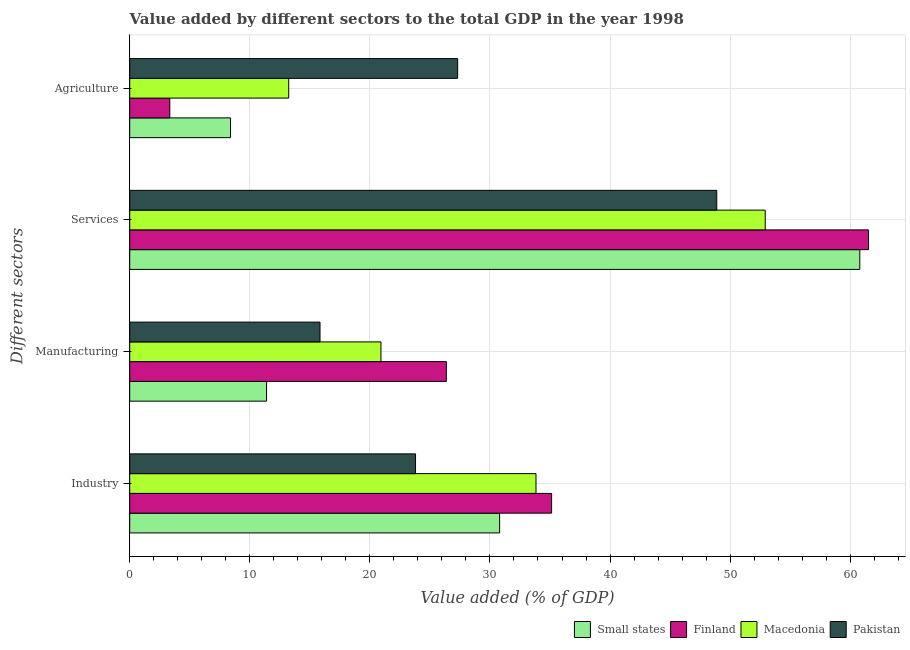How many different coloured bars are there?
Provide a short and direct response. 4. How many groups of bars are there?
Offer a very short reply. 4. How many bars are there on the 3rd tick from the bottom?
Your answer should be compact. 4. What is the label of the 4th group of bars from the top?
Provide a short and direct response. Industry. What is the value added by manufacturing sector in Pakistan?
Provide a succinct answer. 15.85. Across all countries, what is the maximum value added by agricultural sector?
Provide a succinct answer. 27.31. Across all countries, what is the minimum value added by services sector?
Offer a very short reply. 48.89. In which country was the value added by services sector minimum?
Provide a succinct answer. Pakistan. What is the total value added by agricultural sector in the graph?
Provide a succinct answer. 52.28. What is the difference between the value added by industrial sector in Finland and that in Pakistan?
Provide a succinct answer. 11.33. What is the difference between the value added by services sector in Small states and the value added by manufacturing sector in Macedonia?
Provide a succinct answer. 39.88. What is the average value added by industrial sector per country?
Make the answer very short. 30.89. What is the difference between the value added by manufacturing sector and value added by agricultural sector in Pakistan?
Provide a short and direct response. -11.46. What is the ratio of the value added by services sector in Macedonia to that in Finland?
Your answer should be compact. 0.86. Is the value added by services sector in Pakistan less than that in Macedonia?
Make the answer very short. Yes. Is the difference between the value added by industrial sector in Finland and Macedonia greater than the difference between the value added by manufacturing sector in Finland and Macedonia?
Provide a succinct answer. No. What is the difference between the highest and the second highest value added by agricultural sector?
Keep it short and to the point. 14.07. What is the difference between the highest and the lowest value added by industrial sector?
Keep it short and to the point. 11.33. In how many countries, is the value added by industrial sector greater than the average value added by industrial sector taken over all countries?
Provide a succinct answer. 2. What does the 1st bar from the top in Services represents?
Offer a very short reply. Pakistan. Is it the case that in every country, the sum of the value added by industrial sector and value added by manufacturing sector is greater than the value added by services sector?
Give a very brief answer. No. How many bars are there?
Your response must be concise. 16. Are all the bars in the graph horizontal?
Ensure brevity in your answer.  Yes. What is the difference between two consecutive major ticks on the X-axis?
Make the answer very short. 10. Are the values on the major ticks of X-axis written in scientific E-notation?
Ensure brevity in your answer.  No. Does the graph contain grids?
Your answer should be very brief. Yes. Where does the legend appear in the graph?
Provide a short and direct response. Bottom right. What is the title of the graph?
Your answer should be very brief. Value added by different sectors to the total GDP in the year 1998. What is the label or title of the X-axis?
Your answer should be very brief. Value added (% of GDP). What is the label or title of the Y-axis?
Provide a short and direct response. Different sectors. What is the Value added (% of GDP) in Small states in Industry?
Ensure brevity in your answer.  30.81. What is the Value added (% of GDP) of Finland in Industry?
Give a very brief answer. 35.13. What is the Value added (% of GDP) in Macedonia in Industry?
Your response must be concise. 33.83. What is the Value added (% of GDP) of Pakistan in Industry?
Provide a short and direct response. 23.8. What is the Value added (% of GDP) in Small states in Manufacturing?
Give a very brief answer. 11.4. What is the Value added (% of GDP) of Finland in Manufacturing?
Your response must be concise. 26.37. What is the Value added (% of GDP) in Macedonia in Manufacturing?
Offer a terse response. 20.92. What is the Value added (% of GDP) of Pakistan in Manufacturing?
Offer a terse response. 15.85. What is the Value added (% of GDP) of Small states in Services?
Keep it short and to the point. 60.8. What is the Value added (% of GDP) in Finland in Services?
Ensure brevity in your answer.  61.53. What is the Value added (% of GDP) in Macedonia in Services?
Offer a very short reply. 52.92. What is the Value added (% of GDP) in Pakistan in Services?
Keep it short and to the point. 48.89. What is the Value added (% of GDP) in Small states in Agriculture?
Make the answer very short. 8.39. What is the Value added (% of GDP) of Finland in Agriculture?
Keep it short and to the point. 3.34. What is the Value added (% of GDP) in Macedonia in Agriculture?
Offer a very short reply. 13.24. What is the Value added (% of GDP) in Pakistan in Agriculture?
Offer a terse response. 27.31. Across all Different sectors, what is the maximum Value added (% of GDP) in Small states?
Offer a terse response. 60.8. Across all Different sectors, what is the maximum Value added (% of GDP) in Finland?
Provide a short and direct response. 61.53. Across all Different sectors, what is the maximum Value added (% of GDP) of Macedonia?
Provide a succinct answer. 52.92. Across all Different sectors, what is the maximum Value added (% of GDP) of Pakistan?
Ensure brevity in your answer.  48.89. Across all Different sectors, what is the minimum Value added (% of GDP) in Small states?
Provide a succinct answer. 8.39. Across all Different sectors, what is the minimum Value added (% of GDP) in Finland?
Ensure brevity in your answer.  3.34. Across all Different sectors, what is the minimum Value added (% of GDP) of Macedonia?
Give a very brief answer. 13.24. Across all Different sectors, what is the minimum Value added (% of GDP) in Pakistan?
Provide a short and direct response. 15.85. What is the total Value added (% of GDP) of Small states in the graph?
Offer a very short reply. 111.4. What is the total Value added (% of GDP) in Finland in the graph?
Your answer should be compact. 126.37. What is the total Value added (% of GDP) of Macedonia in the graph?
Give a very brief answer. 120.92. What is the total Value added (% of GDP) of Pakistan in the graph?
Ensure brevity in your answer.  115.85. What is the difference between the Value added (% of GDP) in Small states in Industry and that in Manufacturing?
Ensure brevity in your answer.  19.41. What is the difference between the Value added (% of GDP) in Finland in Industry and that in Manufacturing?
Give a very brief answer. 8.77. What is the difference between the Value added (% of GDP) of Macedonia in Industry and that in Manufacturing?
Give a very brief answer. 12.91. What is the difference between the Value added (% of GDP) of Pakistan in Industry and that in Manufacturing?
Offer a very short reply. 7.96. What is the difference between the Value added (% of GDP) of Small states in Industry and that in Services?
Give a very brief answer. -29.99. What is the difference between the Value added (% of GDP) in Finland in Industry and that in Services?
Keep it short and to the point. -26.39. What is the difference between the Value added (% of GDP) of Macedonia in Industry and that in Services?
Make the answer very short. -19.09. What is the difference between the Value added (% of GDP) of Pakistan in Industry and that in Services?
Keep it short and to the point. -25.09. What is the difference between the Value added (% of GDP) in Small states in Industry and that in Agriculture?
Make the answer very short. 22.41. What is the difference between the Value added (% of GDP) in Finland in Industry and that in Agriculture?
Your answer should be very brief. 31.8. What is the difference between the Value added (% of GDP) of Macedonia in Industry and that in Agriculture?
Provide a short and direct response. 20.59. What is the difference between the Value added (% of GDP) in Pakistan in Industry and that in Agriculture?
Your answer should be very brief. -3.51. What is the difference between the Value added (% of GDP) of Small states in Manufacturing and that in Services?
Offer a very short reply. -49.4. What is the difference between the Value added (% of GDP) in Finland in Manufacturing and that in Services?
Give a very brief answer. -35.16. What is the difference between the Value added (% of GDP) of Macedonia in Manufacturing and that in Services?
Your answer should be very brief. -32. What is the difference between the Value added (% of GDP) of Pakistan in Manufacturing and that in Services?
Your answer should be compact. -33.04. What is the difference between the Value added (% of GDP) in Small states in Manufacturing and that in Agriculture?
Keep it short and to the point. 3. What is the difference between the Value added (% of GDP) of Finland in Manufacturing and that in Agriculture?
Provide a succinct answer. 23.03. What is the difference between the Value added (% of GDP) of Macedonia in Manufacturing and that in Agriculture?
Give a very brief answer. 7.68. What is the difference between the Value added (% of GDP) in Pakistan in Manufacturing and that in Agriculture?
Your response must be concise. -11.46. What is the difference between the Value added (% of GDP) of Small states in Services and that in Agriculture?
Make the answer very short. 52.4. What is the difference between the Value added (% of GDP) of Finland in Services and that in Agriculture?
Keep it short and to the point. 58.19. What is the difference between the Value added (% of GDP) in Macedonia in Services and that in Agriculture?
Provide a short and direct response. 39.68. What is the difference between the Value added (% of GDP) of Pakistan in Services and that in Agriculture?
Keep it short and to the point. 21.58. What is the difference between the Value added (% of GDP) of Small states in Industry and the Value added (% of GDP) of Finland in Manufacturing?
Provide a short and direct response. 4.44. What is the difference between the Value added (% of GDP) of Small states in Industry and the Value added (% of GDP) of Macedonia in Manufacturing?
Your response must be concise. 9.88. What is the difference between the Value added (% of GDP) of Small states in Industry and the Value added (% of GDP) of Pakistan in Manufacturing?
Your answer should be compact. 14.96. What is the difference between the Value added (% of GDP) in Finland in Industry and the Value added (% of GDP) in Macedonia in Manufacturing?
Your answer should be very brief. 14.21. What is the difference between the Value added (% of GDP) in Finland in Industry and the Value added (% of GDP) in Pakistan in Manufacturing?
Give a very brief answer. 19.29. What is the difference between the Value added (% of GDP) of Macedonia in Industry and the Value added (% of GDP) of Pakistan in Manufacturing?
Provide a short and direct response. 17.99. What is the difference between the Value added (% of GDP) of Small states in Industry and the Value added (% of GDP) of Finland in Services?
Keep it short and to the point. -30.72. What is the difference between the Value added (% of GDP) of Small states in Industry and the Value added (% of GDP) of Macedonia in Services?
Your answer should be very brief. -22.12. What is the difference between the Value added (% of GDP) in Small states in Industry and the Value added (% of GDP) in Pakistan in Services?
Provide a short and direct response. -18.08. What is the difference between the Value added (% of GDP) of Finland in Industry and the Value added (% of GDP) of Macedonia in Services?
Offer a very short reply. -17.79. What is the difference between the Value added (% of GDP) of Finland in Industry and the Value added (% of GDP) of Pakistan in Services?
Offer a terse response. -13.75. What is the difference between the Value added (% of GDP) in Macedonia in Industry and the Value added (% of GDP) in Pakistan in Services?
Provide a succinct answer. -15.05. What is the difference between the Value added (% of GDP) in Small states in Industry and the Value added (% of GDP) in Finland in Agriculture?
Offer a terse response. 27.47. What is the difference between the Value added (% of GDP) of Small states in Industry and the Value added (% of GDP) of Macedonia in Agriculture?
Make the answer very short. 17.56. What is the difference between the Value added (% of GDP) of Small states in Industry and the Value added (% of GDP) of Pakistan in Agriculture?
Make the answer very short. 3.5. What is the difference between the Value added (% of GDP) of Finland in Industry and the Value added (% of GDP) of Macedonia in Agriculture?
Ensure brevity in your answer.  21.89. What is the difference between the Value added (% of GDP) in Finland in Industry and the Value added (% of GDP) in Pakistan in Agriculture?
Give a very brief answer. 7.82. What is the difference between the Value added (% of GDP) of Macedonia in Industry and the Value added (% of GDP) of Pakistan in Agriculture?
Give a very brief answer. 6.52. What is the difference between the Value added (% of GDP) of Small states in Manufacturing and the Value added (% of GDP) of Finland in Services?
Your answer should be compact. -50.13. What is the difference between the Value added (% of GDP) of Small states in Manufacturing and the Value added (% of GDP) of Macedonia in Services?
Provide a succinct answer. -41.53. What is the difference between the Value added (% of GDP) in Small states in Manufacturing and the Value added (% of GDP) in Pakistan in Services?
Your response must be concise. -37.49. What is the difference between the Value added (% of GDP) of Finland in Manufacturing and the Value added (% of GDP) of Macedonia in Services?
Give a very brief answer. -26.56. What is the difference between the Value added (% of GDP) of Finland in Manufacturing and the Value added (% of GDP) of Pakistan in Services?
Your response must be concise. -22.52. What is the difference between the Value added (% of GDP) in Macedonia in Manufacturing and the Value added (% of GDP) in Pakistan in Services?
Your response must be concise. -27.96. What is the difference between the Value added (% of GDP) of Small states in Manufacturing and the Value added (% of GDP) of Finland in Agriculture?
Your response must be concise. 8.06. What is the difference between the Value added (% of GDP) of Small states in Manufacturing and the Value added (% of GDP) of Macedonia in Agriculture?
Offer a very short reply. -1.84. What is the difference between the Value added (% of GDP) of Small states in Manufacturing and the Value added (% of GDP) of Pakistan in Agriculture?
Provide a short and direct response. -15.91. What is the difference between the Value added (% of GDP) in Finland in Manufacturing and the Value added (% of GDP) in Macedonia in Agriculture?
Offer a very short reply. 13.13. What is the difference between the Value added (% of GDP) of Finland in Manufacturing and the Value added (% of GDP) of Pakistan in Agriculture?
Your response must be concise. -0.94. What is the difference between the Value added (% of GDP) in Macedonia in Manufacturing and the Value added (% of GDP) in Pakistan in Agriculture?
Make the answer very short. -6.39. What is the difference between the Value added (% of GDP) of Small states in Services and the Value added (% of GDP) of Finland in Agriculture?
Your answer should be very brief. 57.46. What is the difference between the Value added (% of GDP) in Small states in Services and the Value added (% of GDP) in Macedonia in Agriculture?
Your answer should be compact. 47.56. What is the difference between the Value added (% of GDP) in Small states in Services and the Value added (% of GDP) in Pakistan in Agriculture?
Keep it short and to the point. 33.49. What is the difference between the Value added (% of GDP) of Finland in Services and the Value added (% of GDP) of Macedonia in Agriculture?
Ensure brevity in your answer.  48.29. What is the difference between the Value added (% of GDP) in Finland in Services and the Value added (% of GDP) in Pakistan in Agriculture?
Your answer should be very brief. 34.22. What is the difference between the Value added (% of GDP) in Macedonia in Services and the Value added (% of GDP) in Pakistan in Agriculture?
Give a very brief answer. 25.61. What is the average Value added (% of GDP) of Small states per Different sectors?
Offer a terse response. 27.85. What is the average Value added (% of GDP) of Finland per Different sectors?
Offer a terse response. 31.59. What is the average Value added (% of GDP) of Macedonia per Different sectors?
Your response must be concise. 30.23. What is the average Value added (% of GDP) of Pakistan per Different sectors?
Offer a very short reply. 28.96. What is the difference between the Value added (% of GDP) of Small states and Value added (% of GDP) of Finland in Industry?
Give a very brief answer. -4.33. What is the difference between the Value added (% of GDP) of Small states and Value added (% of GDP) of Macedonia in Industry?
Your answer should be very brief. -3.03. What is the difference between the Value added (% of GDP) of Small states and Value added (% of GDP) of Pakistan in Industry?
Provide a succinct answer. 7. What is the difference between the Value added (% of GDP) of Finland and Value added (% of GDP) of Macedonia in Industry?
Make the answer very short. 1.3. What is the difference between the Value added (% of GDP) in Finland and Value added (% of GDP) in Pakistan in Industry?
Your response must be concise. 11.33. What is the difference between the Value added (% of GDP) in Macedonia and Value added (% of GDP) in Pakistan in Industry?
Provide a succinct answer. 10.03. What is the difference between the Value added (% of GDP) in Small states and Value added (% of GDP) in Finland in Manufacturing?
Your answer should be compact. -14.97. What is the difference between the Value added (% of GDP) in Small states and Value added (% of GDP) in Macedonia in Manufacturing?
Offer a terse response. -9.53. What is the difference between the Value added (% of GDP) in Small states and Value added (% of GDP) in Pakistan in Manufacturing?
Make the answer very short. -4.45. What is the difference between the Value added (% of GDP) in Finland and Value added (% of GDP) in Macedonia in Manufacturing?
Your response must be concise. 5.44. What is the difference between the Value added (% of GDP) of Finland and Value added (% of GDP) of Pakistan in Manufacturing?
Your answer should be very brief. 10.52. What is the difference between the Value added (% of GDP) of Macedonia and Value added (% of GDP) of Pakistan in Manufacturing?
Keep it short and to the point. 5.08. What is the difference between the Value added (% of GDP) in Small states and Value added (% of GDP) in Finland in Services?
Your answer should be very brief. -0.73. What is the difference between the Value added (% of GDP) in Small states and Value added (% of GDP) in Macedonia in Services?
Ensure brevity in your answer.  7.88. What is the difference between the Value added (% of GDP) in Small states and Value added (% of GDP) in Pakistan in Services?
Provide a short and direct response. 11.91. What is the difference between the Value added (% of GDP) of Finland and Value added (% of GDP) of Macedonia in Services?
Give a very brief answer. 8.6. What is the difference between the Value added (% of GDP) of Finland and Value added (% of GDP) of Pakistan in Services?
Offer a terse response. 12.64. What is the difference between the Value added (% of GDP) in Macedonia and Value added (% of GDP) in Pakistan in Services?
Provide a succinct answer. 4.04. What is the difference between the Value added (% of GDP) of Small states and Value added (% of GDP) of Finland in Agriculture?
Keep it short and to the point. 5.06. What is the difference between the Value added (% of GDP) in Small states and Value added (% of GDP) in Macedonia in Agriculture?
Ensure brevity in your answer.  -4.85. What is the difference between the Value added (% of GDP) of Small states and Value added (% of GDP) of Pakistan in Agriculture?
Offer a very short reply. -18.92. What is the difference between the Value added (% of GDP) in Finland and Value added (% of GDP) in Macedonia in Agriculture?
Provide a short and direct response. -9.9. What is the difference between the Value added (% of GDP) in Finland and Value added (% of GDP) in Pakistan in Agriculture?
Your answer should be very brief. -23.97. What is the difference between the Value added (% of GDP) in Macedonia and Value added (% of GDP) in Pakistan in Agriculture?
Offer a terse response. -14.07. What is the ratio of the Value added (% of GDP) in Small states in Industry to that in Manufacturing?
Provide a short and direct response. 2.7. What is the ratio of the Value added (% of GDP) of Finland in Industry to that in Manufacturing?
Keep it short and to the point. 1.33. What is the ratio of the Value added (% of GDP) in Macedonia in Industry to that in Manufacturing?
Offer a very short reply. 1.62. What is the ratio of the Value added (% of GDP) in Pakistan in Industry to that in Manufacturing?
Offer a very short reply. 1.5. What is the ratio of the Value added (% of GDP) of Small states in Industry to that in Services?
Ensure brevity in your answer.  0.51. What is the ratio of the Value added (% of GDP) of Finland in Industry to that in Services?
Make the answer very short. 0.57. What is the ratio of the Value added (% of GDP) of Macedonia in Industry to that in Services?
Provide a succinct answer. 0.64. What is the ratio of the Value added (% of GDP) of Pakistan in Industry to that in Services?
Keep it short and to the point. 0.49. What is the ratio of the Value added (% of GDP) of Small states in Industry to that in Agriculture?
Ensure brevity in your answer.  3.67. What is the ratio of the Value added (% of GDP) of Finland in Industry to that in Agriculture?
Ensure brevity in your answer.  10.53. What is the ratio of the Value added (% of GDP) in Macedonia in Industry to that in Agriculture?
Your answer should be compact. 2.56. What is the ratio of the Value added (% of GDP) of Pakistan in Industry to that in Agriculture?
Keep it short and to the point. 0.87. What is the ratio of the Value added (% of GDP) in Small states in Manufacturing to that in Services?
Your answer should be compact. 0.19. What is the ratio of the Value added (% of GDP) in Finland in Manufacturing to that in Services?
Offer a very short reply. 0.43. What is the ratio of the Value added (% of GDP) of Macedonia in Manufacturing to that in Services?
Your response must be concise. 0.4. What is the ratio of the Value added (% of GDP) of Pakistan in Manufacturing to that in Services?
Offer a terse response. 0.32. What is the ratio of the Value added (% of GDP) in Small states in Manufacturing to that in Agriculture?
Provide a short and direct response. 1.36. What is the ratio of the Value added (% of GDP) of Finland in Manufacturing to that in Agriculture?
Ensure brevity in your answer.  7.9. What is the ratio of the Value added (% of GDP) of Macedonia in Manufacturing to that in Agriculture?
Give a very brief answer. 1.58. What is the ratio of the Value added (% of GDP) in Pakistan in Manufacturing to that in Agriculture?
Your answer should be compact. 0.58. What is the ratio of the Value added (% of GDP) of Small states in Services to that in Agriculture?
Ensure brevity in your answer.  7.24. What is the ratio of the Value added (% of GDP) in Finland in Services to that in Agriculture?
Ensure brevity in your answer.  18.44. What is the ratio of the Value added (% of GDP) of Macedonia in Services to that in Agriculture?
Your answer should be very brief. 4. What is the ratio of the Value added (% of GDP) in Pakistan in Services to that in Agriculture?
Give a very brief answer. 1.79. What is the difference between the highest and the second highest Value added (% of GDP) of Small states?
Provide a short and direct response. 29.99. What is the difference between the highest and the second highest Value added (% of GDP) in Finland?
Offer a terse response. 26.39. What is the difference between the highest and the second highest Value added (% of GDP) of Macedonia?
Offer a terse response. 19.09. What is the difference between the highest and the second highest Value added (% of GDP) of Pakistan?
Offer a very short reply. 21.58. What is the difference between the highest and the lowest Value added (% of GDP) of Small states?
Make the answer very short. 52.4. What is the difference between the highest and the lowest Value added (% of GDP) in Finland?
Provide a succinct answer. 58.19. What is the difference between the highest and the lowest Value added (% of GDP) in Macedonia?
Keep it short and to the point. 39.68. What is the difference between the highest and the lowest Value added (% of GDP) of Pakistan?
Your answer should be compact. 33.04. 